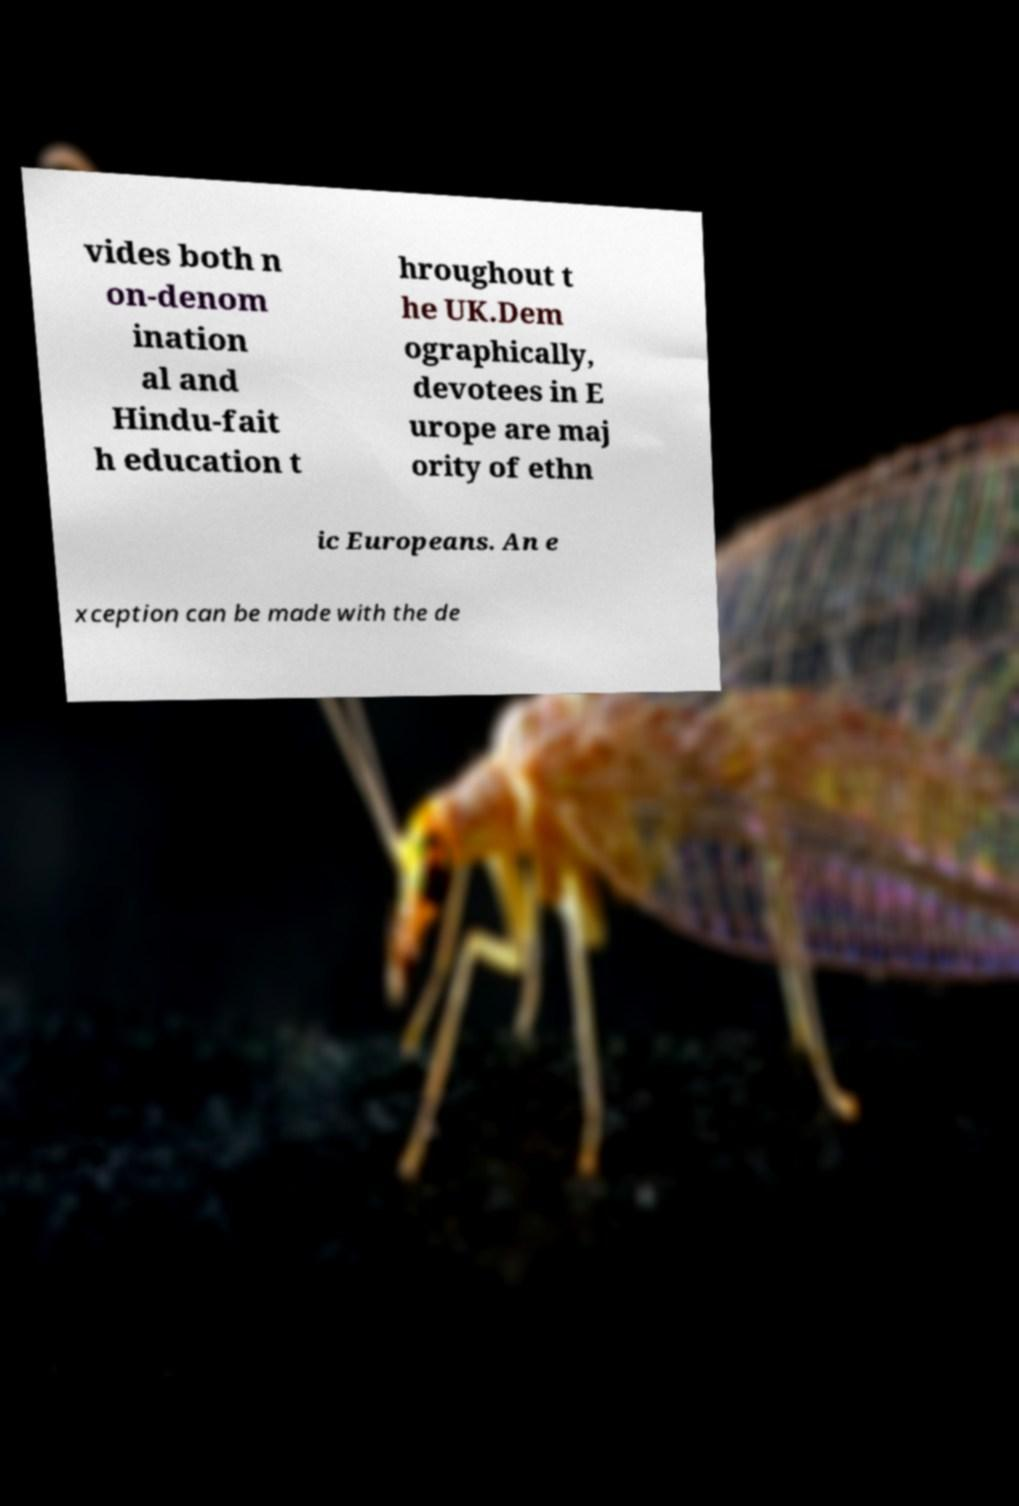Can you accurately transcribe the text from the provided image for me? vides both n on-denom ination al and Hindu-fait h education t hroughout t he UK.Dem ographically, devotees in E urope are maj ority of ethn ic Europeans. An e xception can be made with the de 